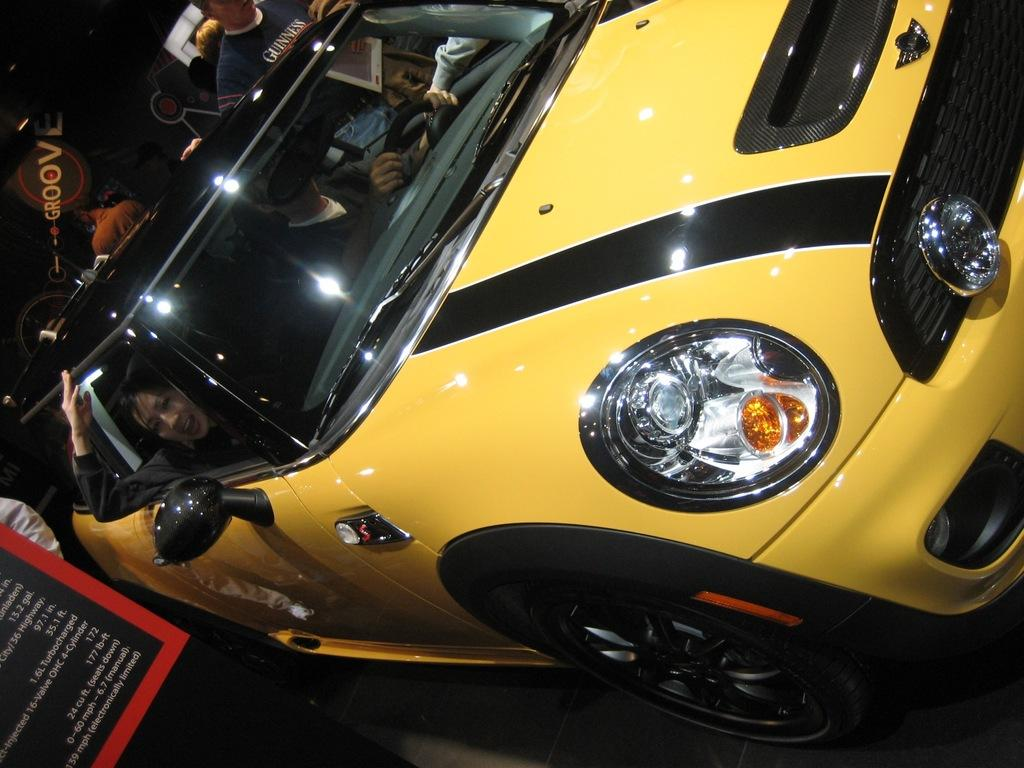What is the color of the car in the image? The car in the image is yellow. What are the two persons inside the car doing? The information provided does not specify what the persons are doing inside the car. What can be seen beside the car? There is a banner beside the car. What is happening in the background of the image? There are people standing in the background. What type of animal is playing the guitar in the image? There is no animal or guitar present in the image. 